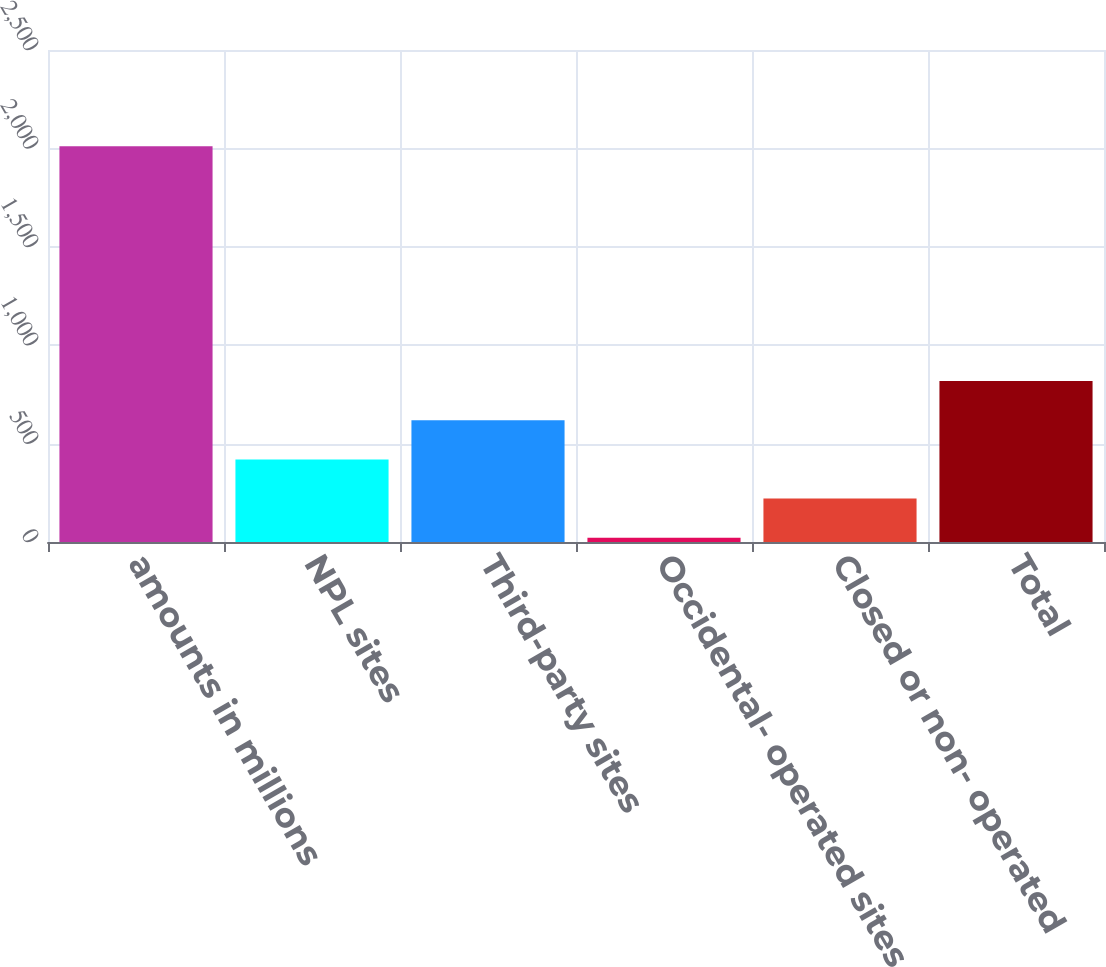Convert chart. <chart><loc_0><loc_0><loc_500><loc_500><bar_chart><fcel>amounts in millions<fcel>NPL sites<fcel>Third-party sites<fcel>Occidental- operated sites<fcel>Closed or non- operated<fcel>Total<nl><fcel>2011<fcel>419.8<fcel>618.7<fcel>22<fcel>220.9<fcel>817.6<nl></chart> 